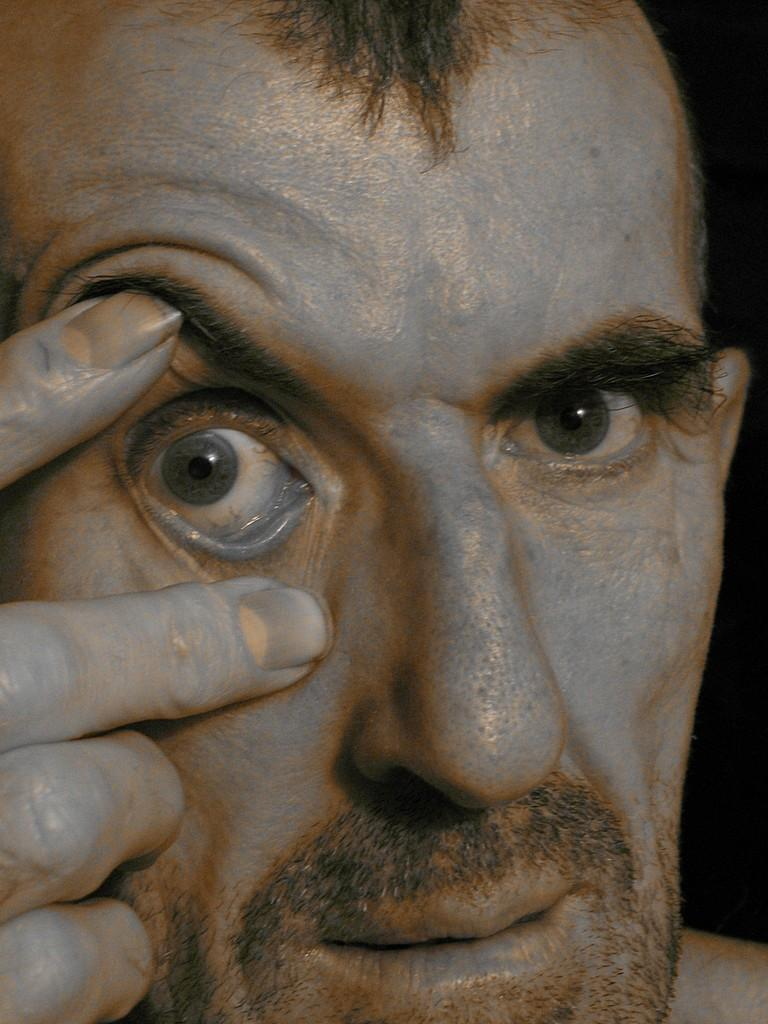What is the main subject of the image? There is a man's face in the image. Can you describe the background of the image? The background of the image is dark. How many bees can be seen buzzing around the dirt in the image? There is no dirt or bees present in the image; it features a man's face with a dark background. 